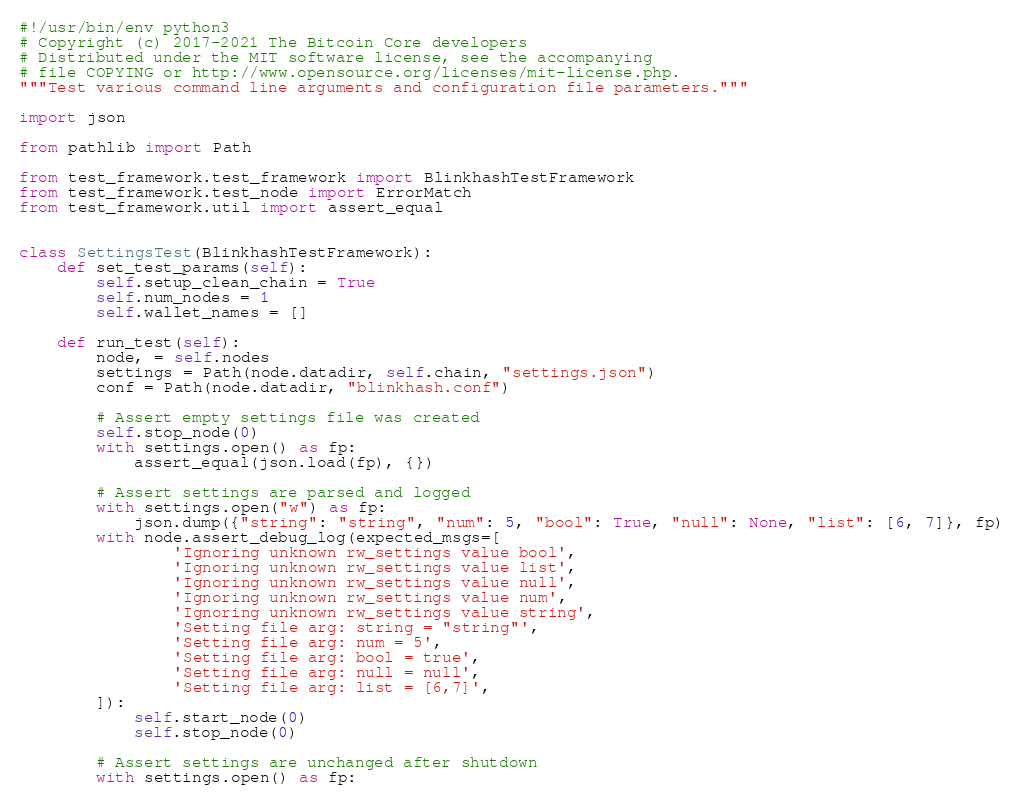Convert code to text. <code><loc_0><loc_0><loc_500><loc_500><_Python_>#!/usr/bin/env python3
# Copyright (c) 2017-2021 The Bitcoin Core developers
# Distributed under the MIT software license, see the accompanying
# file COPYING or http://www.opensource.org/licenses/mit-license.php.
"""Test various command line arguments and configuration file parameters."""

import json

from pathlib import Path

from test_framework.test_framework import BlinkhashTestFramework
from test_framework.test_node import ErrorMatch
from test_framework.util import assert_equal


class SettingsTest(BlinkhashTestFramework):
    def set_test_params(self):
        self.setup_clean_chain = True
        self.num_nodes = 1
        self.wallet_names = []

    def run_test(self):
        node, = self.nodes
        settings = Path(node.datadir, self.chain, "settings.json")
        conf = Path(node.datadir, "blinkhash.conf")

        # Assert empty settings file was created
        self.stop_node(0)
        with settings.open() as fp:
            assert_equal(json.load(fp), {})

        # Assert settings are parsed and logged
        with settings.open("w") as fp:
            json.dump({"string": "string", "num": 5, "bool": True, "null": None, "list": [6, 7]}, fp)
        with node.assert_debug_log(expected_msgs=[
                'Ignoring unknown rw_settings value bool',
                'Ignoring unknown rw_settings value list',
                'Ignoring unknown rw_settings value null',
                'Ignoring unknown rw_settings value num',
                'Ignoring unknown rw_settings value string',
                'Setting file arg: string = "string"',
                'Setting file arg: num = 5',
                'Setting file arg: bool = true',
                'Setting file arg: null = null',
                'Setting file arg: list = [6,7]',
        ]):
            self.start_node(0)
            self.stop_node(0)

        # Assert settings are unchanged after shutdown
        with settings.open() as fp:</code> 